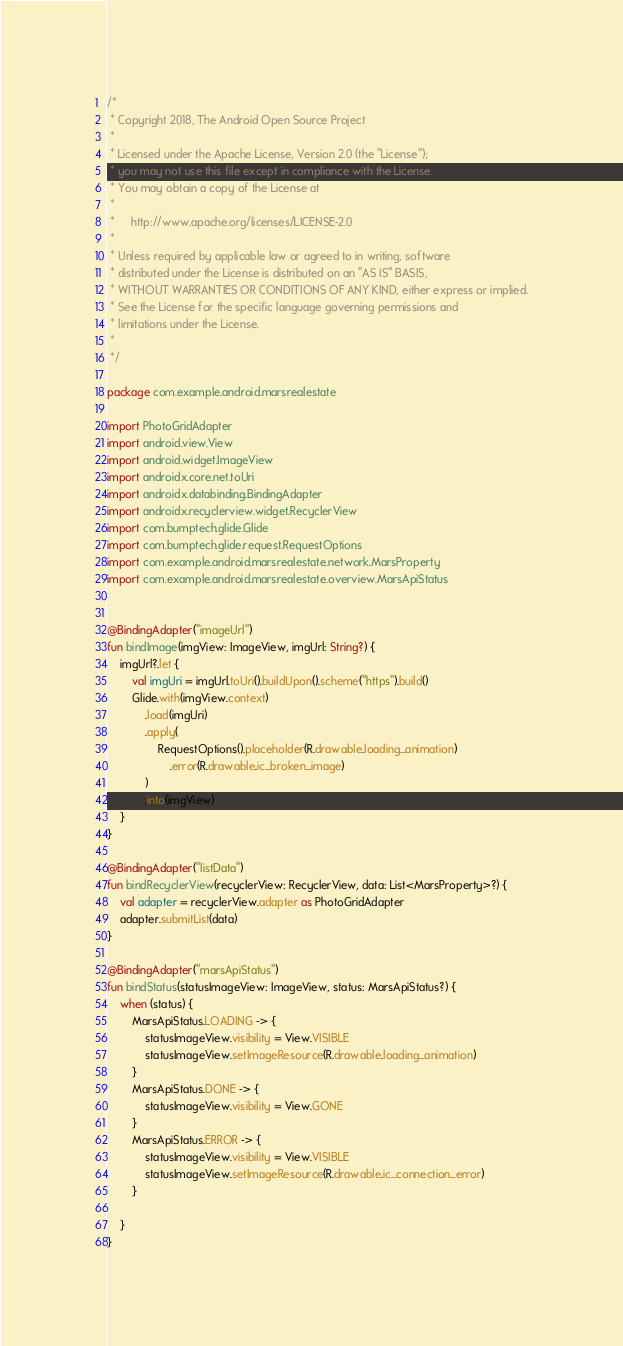<code> <loc_0><loc_0><loc_500><loc_500><_Kotlin_>/*
 * Copyright 2018, The Android Open Source Project
 *
 * Licensed under the Apache License, Version 2.0 (the "License");
 * you may not use this file except in compliance with the License.
 * You may obtain a copy of the License at
 *
 *     http://www.apache.org/licenses/LICENSE-2.0
 *
 * Unless required by applicable law or agreed to in writing, software
 * distributed under the License is distributed on an "AS IS" BASIS,
 * WITHOUT WARRANTIES OR CONDITIONS OF ANY KIND, either express or implied.
 * See the License for the specific language governing permissions and
 * limitations under the License.
 *
 */

package com.example.android.marsrealestate

import PhotoGridAdapter
import android.view.View
import android.widget.ImageView
import androidx.core.net.toUri
import androidx.databinding.BindingAdapter
import androidx.recyclerview.widget.RecyclerView
import com.bumptech.glide.Glide
import com.bumptech.glide.request.RequestOptions
import com.example.android.marsrealestate.network.MarsProperty
import com.example.android.marsrealestate.overview.MarsApiStatus


@BindingAdapter("imageUrl")
fun bindImage(imgView: ImageView, imgUrl: String?) {
    imgUrl?.let {
        val imgUri = imgUrl.toUri().buildUpon().scheme("https").build()
        Glide.with(imgView.context)
            .load(imgUri)
            .apply(
                RequestOptions().placeholder(R.drawable.loading_animation)
                    .error(R.drawable.ic_broken_image)
            )
            .into(imgView)
    }
}

@BindingAdapter("listData")
fun bindRecyclerView(recyclerView: RecyclerView, data: List<MarsProperty>?) {
    val adapter = recyclerView.adapter as PhotoGridAdapter
    adapter.submitList(data)
}

@BindingAdapter("marsApiStatus")
fun bindStatus(statusImageView: ImageView, status: MarsApiStatus?) {
    when (status) {
        MarsApiStatus.LOADING -> {
            statusImageView.visibility = View.VISIBLE
            statusImageView.setImageResource(R.drawable.loading_animation)
        }
        MarsApiStatus.DONE -> {
            statusImageView.visibility = View.GONE
        }
        MarsApiStatus.ERROR -> {
            statusImageView.visibility = View.VISIBLE
            statusImageView.setImageResource(R.drawable.ic_connection_error)
        }

    }
}</code> 